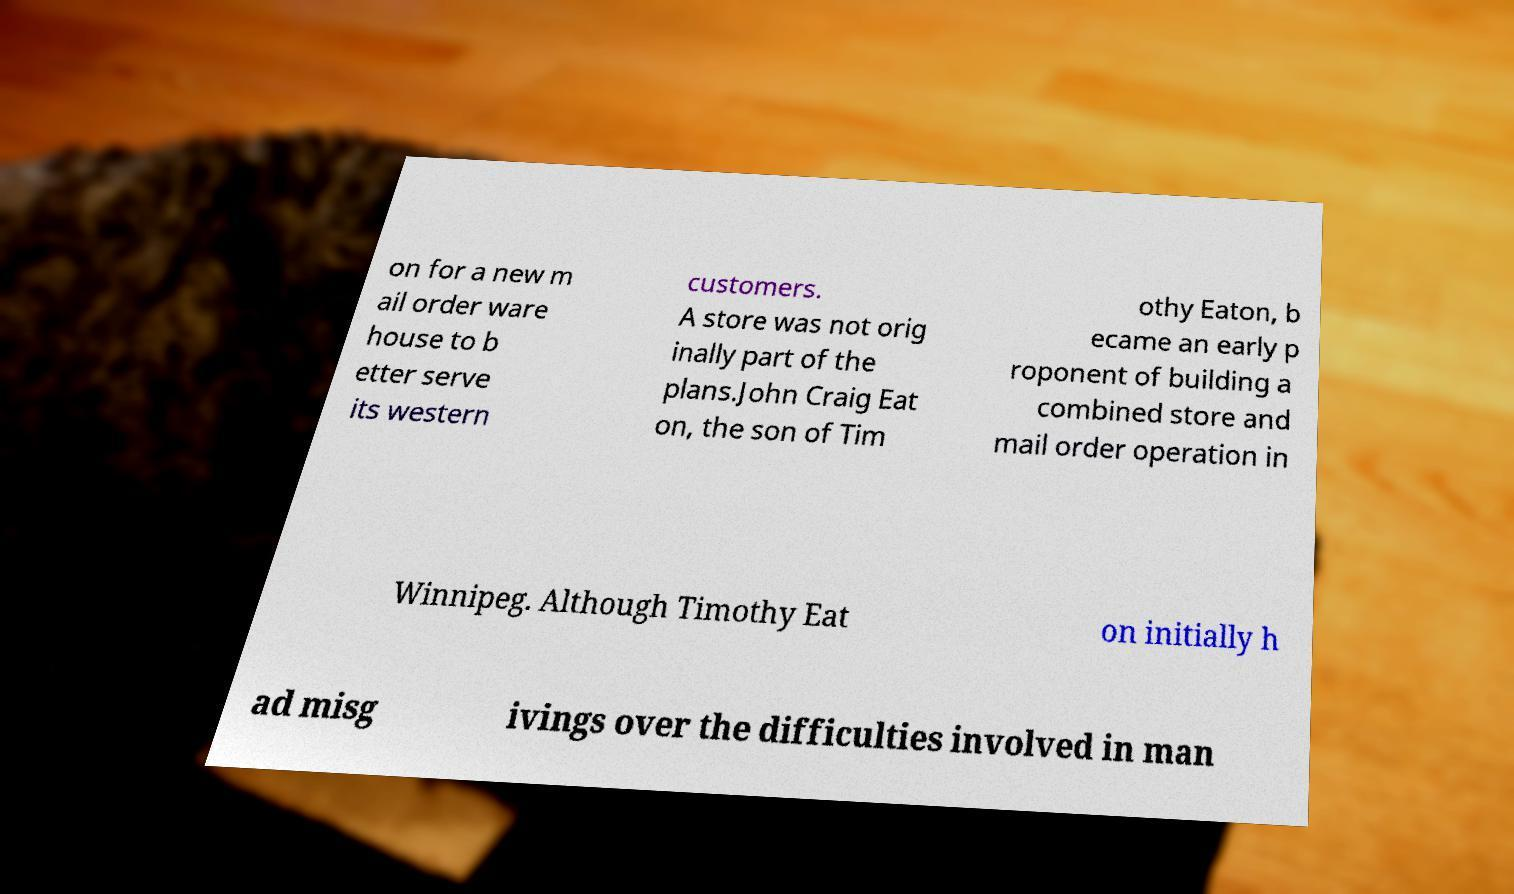Please identify and transcribe the text found in this image. on for a new m ail order ware house to b etter serve its western customers. A store was not orig inally part of the plans.John Craig Eat on, the son of Tim othy Eaton, b ecame an early p roponent of building a combined store and mail order operation in Winnipeg. Although Timothy Eat on initially h ad misg ivings over the difficulties involved in man 